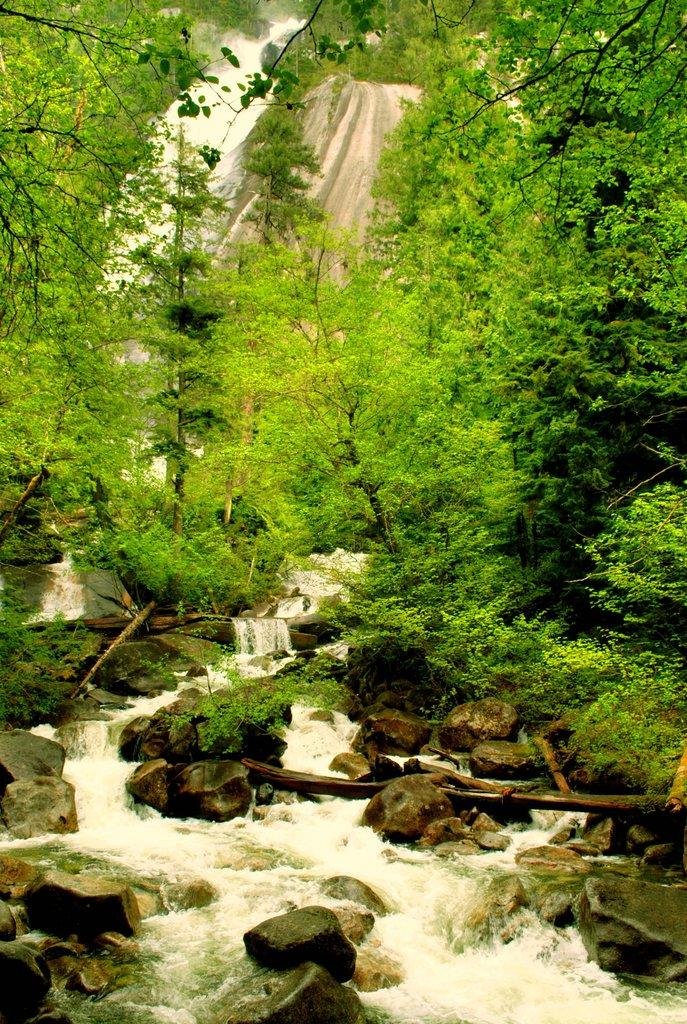What type of natural environment is depicted in the image? The image contains a forest view. Are there any specific landforms visible in the image? Yes, there is a hill and a waterfall in the image. What types of natural elements can be seen in the image? Plants and rocks are visible in the image. What is happening with the water near the rocks in the image? Water is flowing near the rocks in the image. What type of marble is used to decorate the house in the image? There is no house present in the image, and therefore no marble can be observed. What is the shape of the heart-shaped rock in the image? There is no heart-shaped rock present in the image. 